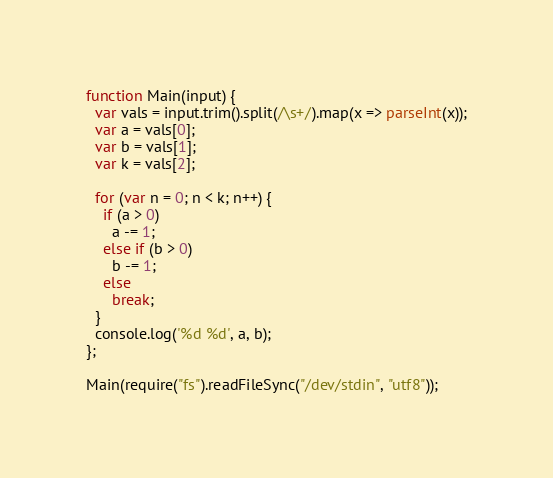<code> <loc_0><loc_0><loc_500><loc_500><_JavaScript_>function Main(input) {
  var vals = input.trim().split(/\s+/).map(x => parseInt(x));
  var a = vals[0];
  var b = vals[1];
  var k = vals[2];
  
  for (var n = 0; n < k; n++) {
    if (a > 0)
      a -= 1;
    else if (b > 0)
      b -= 1;
    else
      break;
  }
  console.log('%d %d', a, b);
};
 
Main(require("fs").readFileSync("/dev/stdin", "utf8"));
</code> 